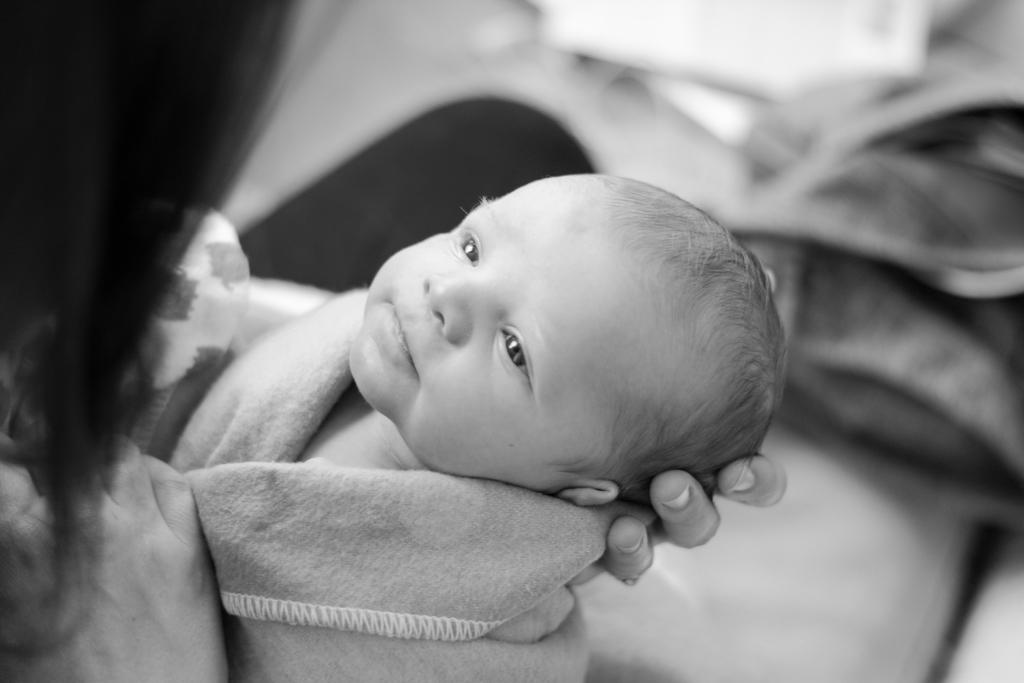What is the color scheme of the image? The image is black and white. What can be seen on the left side of the image? There is a person holding a baby on the left side of the image. What type of cracker is being used to join the baby and person in the image? There is no cracker present in the image, and the baby and person are not being joined by any object. 